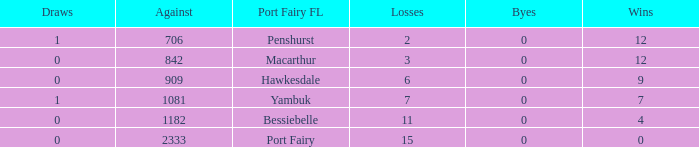How many byes when the draws are less than 0? 0.0. 